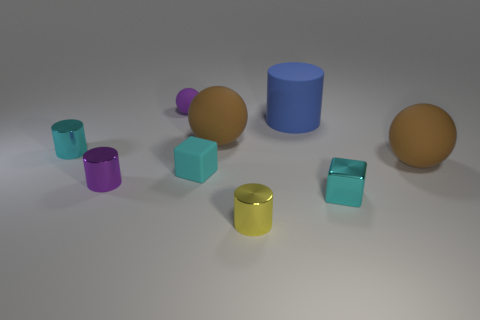The small metallic thing that is the same color as the small metallic cube is what shape?
Ensure brevity in your answer.  Cylinder. There is a cylinder that is the same color as the small rubber sphere; what material is it?
Offer a terse response. Metal. Do the thing on the left side of the tiny purple shiny cylinder and the small metal block have the same color?
Provide a succinct answer. Yes. What is the size of the blue object?
Your answer should be compact. Large. There is a ball that is the same size as the purple cylinder; what material is it?
Offer a very short reply. Rubber. What is the color of the matte thing that is on the left side of the rubber cube?
Offer a terse response. Purple. How many brown things are there?
Ensure brevity in your answer.  2. There is a ball that is to the right of the metallic cylinder that is in front of the small metallic block; are there any small yellow objects right of it?
Make the answer very short. No. The purple matte thing that is the same size as the shiny cube is what shape?
Keep it short and to the point. Sphere. How many other objects are there of the same color as the big rubber cylinder?
Provide a short and direct response. 0. 